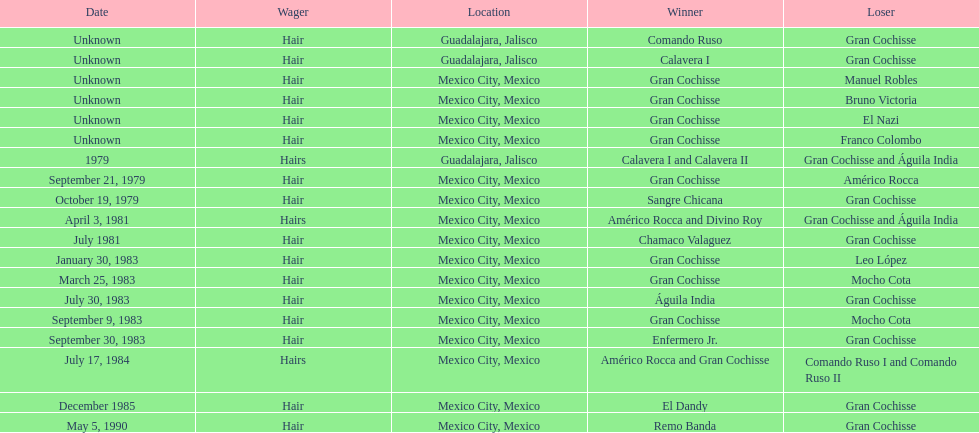When did bruno victoria lose his first game? Unknown. Parse the table in full. {'header': ['Date', 'Wager', 'Location', 'Winner', 'Loser'], 'rows': [['Unknown', 'Hair', 'Guadalajara, Jalisco', 'Comando Ruso', 'Gran Cochisse'], ['Unknown', 'Hair', 'Guadalajara, Jalisco', 'Calavera I', 'Gran Cochisse'], ['Unknown', 'Hair', 'Mexico City, Mexico', 'Gran Cochisse', 'Manuel Robles'], ['Unknown', 'Hair', 'Mexico City, Mexico', 'Gran Cochisse', 'Bruno Victoria'], ['Unknown', 'Hair', 'Mexico City, Mexico', 'Gran Cochisse', 'El Nazi'], ['Unknown', 'Hair', 'Mexico City, Mexico', 'Gran Cochisse', 'Franco Colombo'], ['1979', 'Hairs', 'Guadalajara, Jalisco', 'Calavera I and Calavera II', 'Gran Cochisse and Águila India'], ['September 21, 1979', 'Hair', 'Mexico City, Mexico', 'Gran Cochisse', 'Américo Rocca'], ['October 19, 1979', 'Hair', 'Mexico City, Mexico', 'Sangre Chicana', 'Gran Cochisse'], ['April 3, 1981', 'Hairs', 'Mexico City, Mexico', 'Américo Rocca and Divino Roy', 'Gran Cochisse and Águila India'], ['July 1981', 'Hair', 'Mexico City, Mexico', 'Chamaco Valaguez', 'Gran Cochisse'], ['January 30, 1983', 'Hair', 'Mexico City, Mexico', 'Gran Cochisse', 'Leo López'], ['March 25, 1983', 'Hair', 'Mexico City, Mexico', 'Gran Cochisse', 'Mocho Cota'], ['July 30, 1983', 'Hair', 'Mexico City, Mexico', 'Águila India', 'Gran Cochisse'], ['September 9, 1983', 'Hair', 'Mexico City, Mexico', 'Gran Cochisse', 'Mocho Cota'], ['September 30, 1983', 'Hair', 'Mexico City, Mexico', 'Enfermero Jr.', 'Gran Cochisse'], ['July 17, 1984', 'Hairs', 'Mexico City, Mexico', 'Américo Rocca and Gran Cochisse', 'Comando Ruso I and Comando Ruso II'], ['December 1985', 'Hair', 'Mexico City, Mexico', 'El Dandy', 'Gran Cochisse'], ['May 5, 1990', 'Hair', 'Mexico City, Mexico', 'Remo Banda', 'Gran Cochisse']]} 